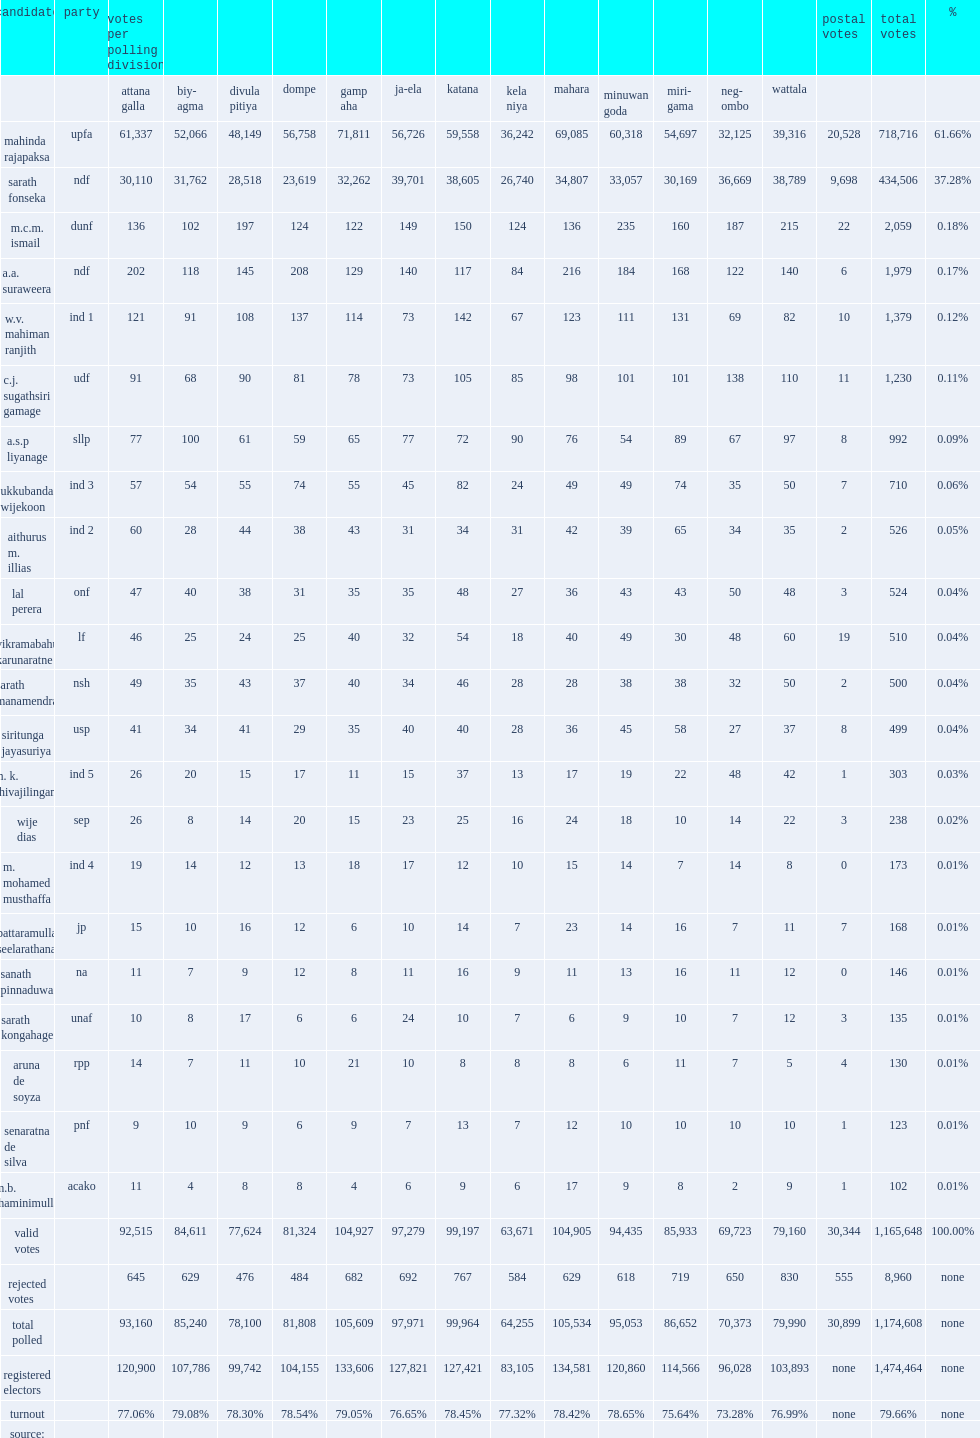What was the total number of votes for gampaha electoral district in 2010? 1474464.0. 